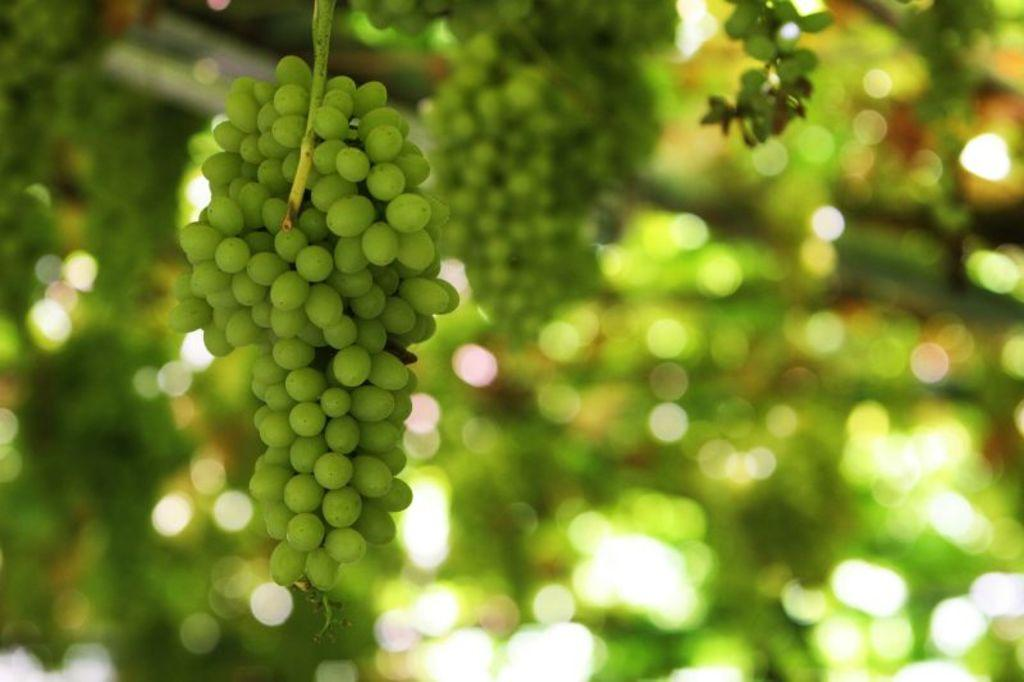What type of fruit is visible in the image? There are grapes in the image. How would you describe the background of the image? The background of the image is blurred. What can be seen in the background of the image besides the blurred area? There is greenery in the background of the image. What type of vest is being worn by the grapes in the image? There are no people or clothing items present in the image, so it is not possible to determine if any grapes are wearing a vest. 